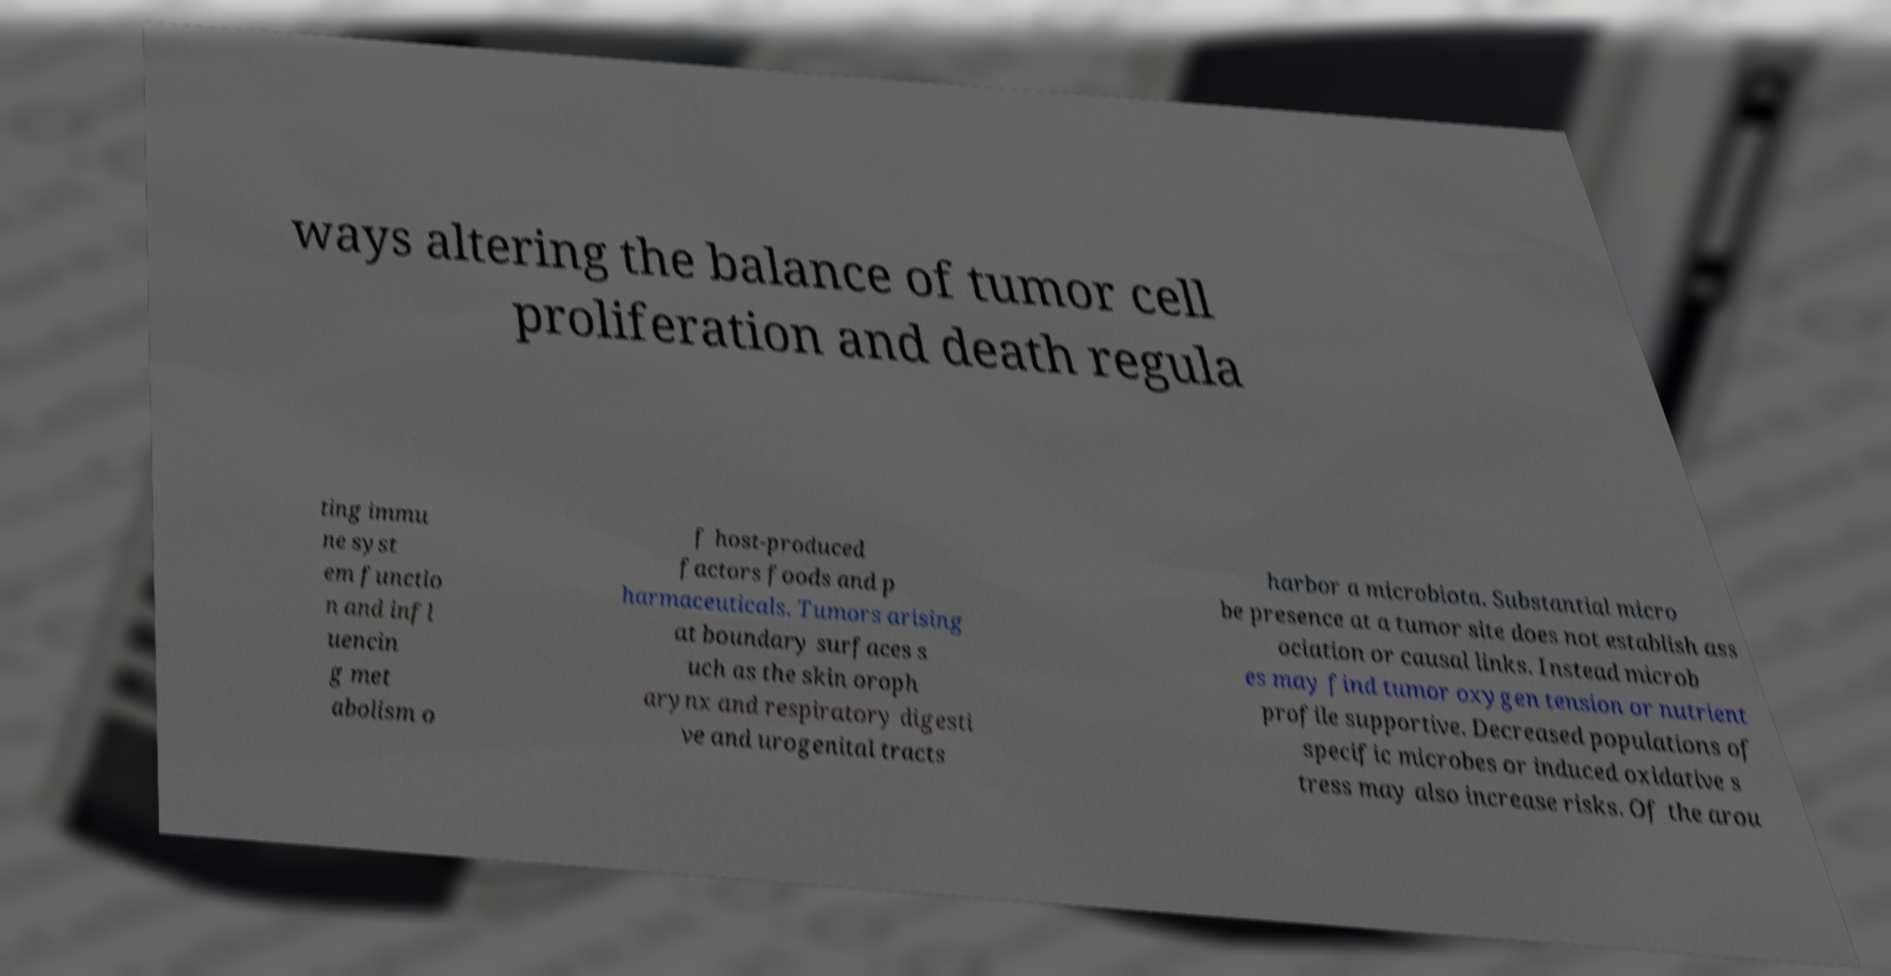Could you assist in decoding the text presented in this image and type it out clearly? ways altering the balance of tumor cell proliferation and death regula ting immu ne syst em functio n and infl uencin g met abolism o f host-produced factors foods and p harmaceuticals. Tumors arising at boundary surfaces s uch as the skin oroph arynx and respiratory digesti ve and urogenital tracts harbor a microbiota. Substantial micro be presence at a tumor site does not establish ass ociation or causal links. Instead microb es may find tumor oxygen tension or nutrient profile supportive. Decreased populations of specific microbes or induced oxidative s tress may also increase risks. Of the arou 